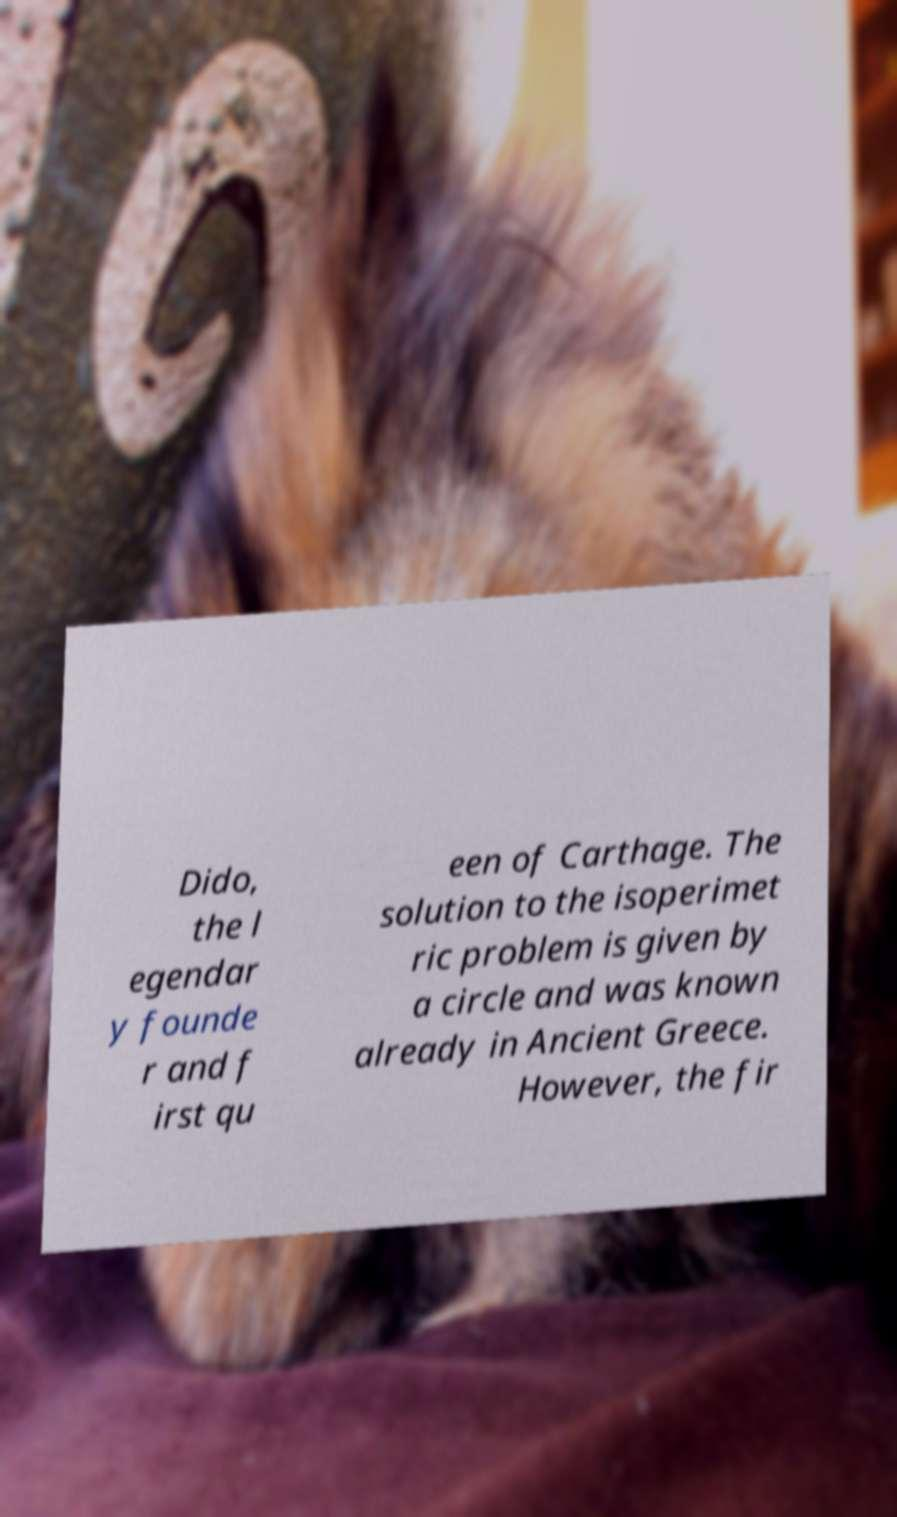For documentation purposes, I need the text within this image transcribed. Could you provide that? Dido, the l egendar y founde r and f irst qu een of Carthage. The solution to the isoperimet ric problem is given by a circle and was known already in Ancient Greece. However, the fir 